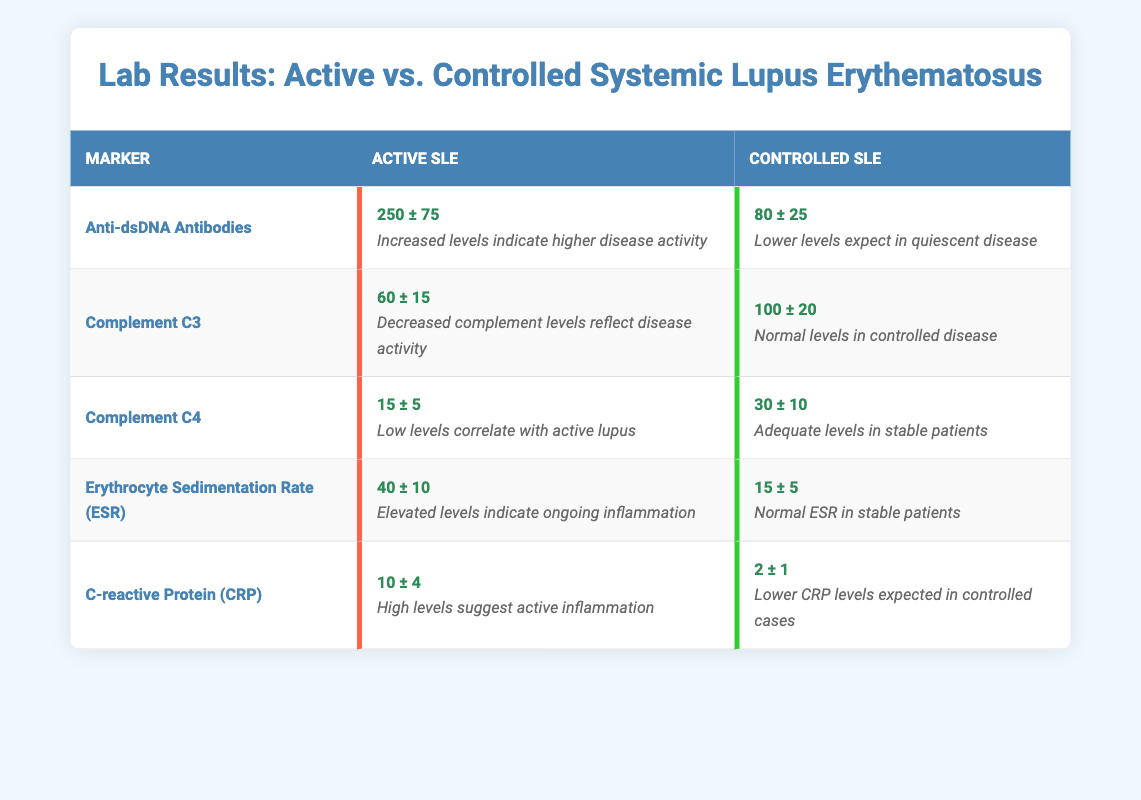What is the mean value of Anti-dsDNA Antibodies in patients with active systemic lupus erythematosus? From the table under the row for Anti-dsDNA Antibodies, the mean value for active systemic lupus erythematosus is clearly listed as 250.
Answer: 250 What are the mean values of Complement C3 for both active and controlled systemic lupus erythematosus? The mean value for Complement C3 in active systemic lupus erythematosus is 60, while in controlled systemic lupus erythematosus, it is 100, as can be seen in the table.
Answer: Active: 60, Controlled: 100 Is the Erythrocyte Sedimentation Rate (ESR) higher in active or controlled systemic lupus erythematosus? By comparing the values in the table, active systemic lupus erythematosus has an ESR of 40, whereas controlled systemic lupus erythematosus has an ESR of 15. Therefore, the ESR is higher in active cases.
Answer: Higher in active What is the difference in mean value between Complement C4 in active versus controlled systemic lupus erythematosus? The mean value for Complement C4 in active systemic lupus erythematosus is 15 and in controlled systemic lupus erythematosus is 30. The difference is calculated as 30 - 15 = 15.
Answer: 15 Are the levels of C-reactive Protein (CRP) observed in active systemic lupus erythematosus higher than those in controlled systemic lupus erythematosus? The values listed in the table show CRP at 10 for active and 2 for controlled systemic lupus erythematosus. Since 10 is greater than 2, the levels are indeed higher in active cases.
Answer: Yes What is the average mean value of the five markers listed for controlled systemic lupus erythematosus? The mean values for controlled systemic lupus erythematosus are: Anti-dsDNA Antibodies (80), Complement C3 (100), Complement C4 (30), ESR (15), and CRP (2). Summing these gives 80 + 100 + 30 + 15 + 2 = 227, and dividing by 5 gives an average of 227 / 5 = 45.4.
Answer: 45.4 Does the mean value of Complement C3 fall within the normal range based on its summary statement? The summary statement for Complement C3 in controlled systemic lupus erythematosus indicates normal levels. Since the mean value is 100, which fits this criterion, the answer is yes.
Answer: Yes Which marker shows the greatest disparity in mean values between active and controlled systemic lupus erythematosus? Checking the differences: Anti-dsDNA Antibodies (250 vs 80 = 170), Complement C3 (60 vs 100 = 40), Complement C4 (15 vs 30 = 15), ESR (40 vs 15 = 25), CRP (10 vs 2 = 8). The largest disparity is from Anti-dsDNA Antibodies with a difference of 170.
Answer: Anti-dsDNA Antibodies 